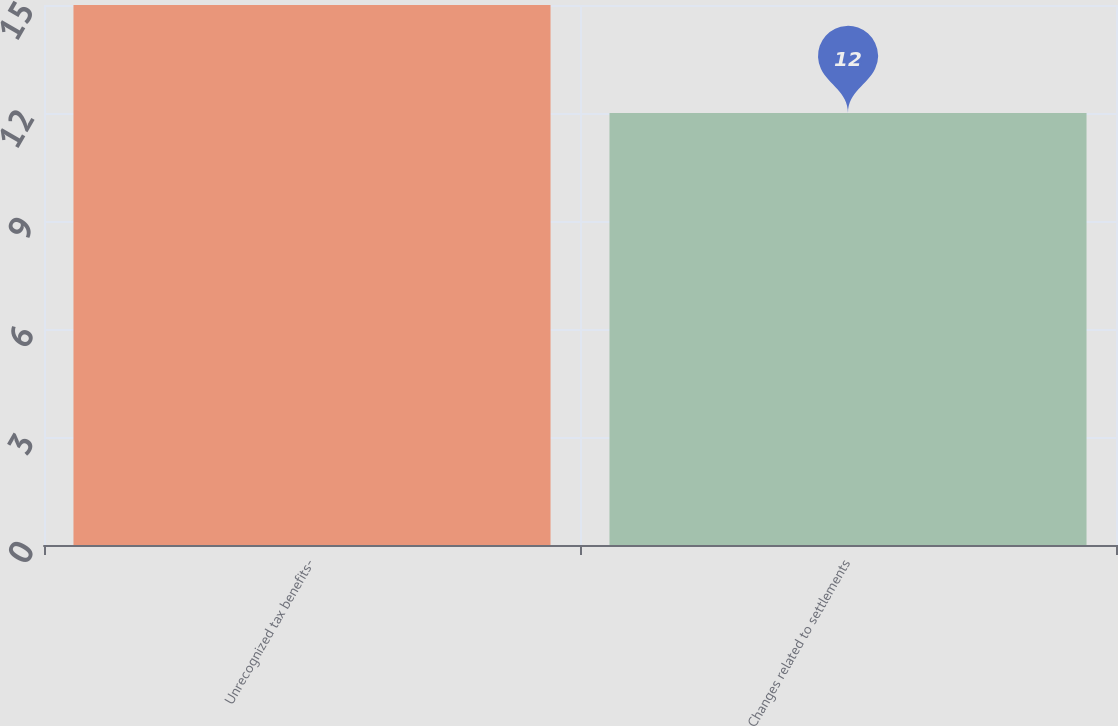Convert chart to OTSL. <chart><loc_0><loc_0><loc_500><loc_500><bar_chart><fcel>Unrecognized tax benefits-<fcel>Changes related to settlements<nl><fcel>15<fcel>12<nl></chart> 